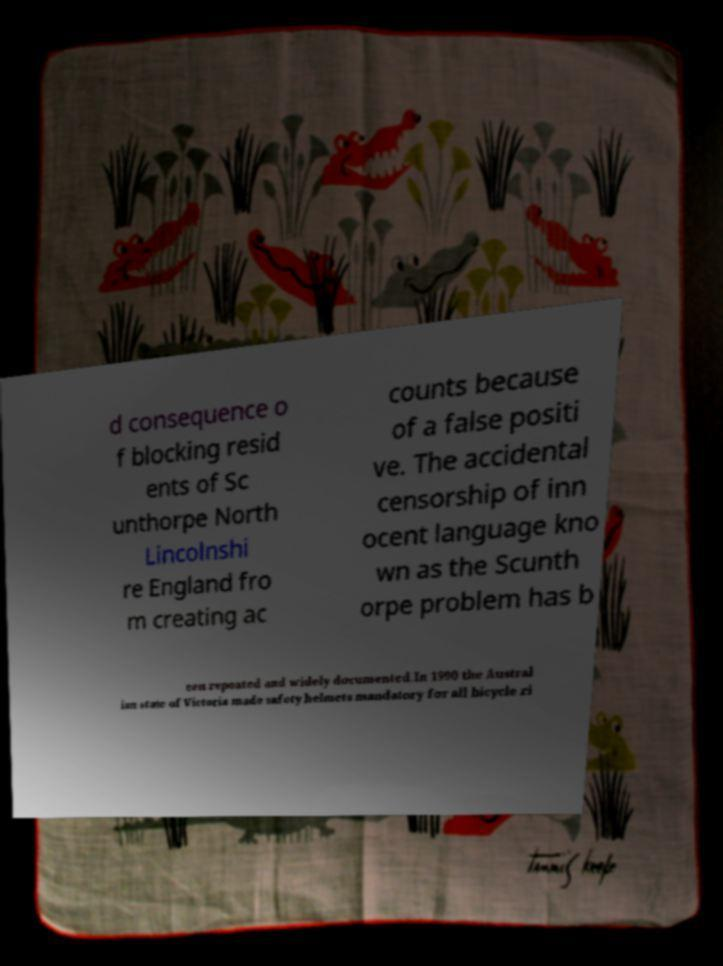There's text embedded in this image that I need extracted. Can you transcribe it verbatim? d consequence o f blocking resid ents of Sc unthorpe North Lincolnshi re England fro m creating ac counts because of a false positi ve. The accidental censorship of inn ocent language kno wn as the Scunth orpe problem has b een repeated and widely documented.In 1990 the Austral ian state of Victoria made safety helmets mandatory for all bicycle ri 